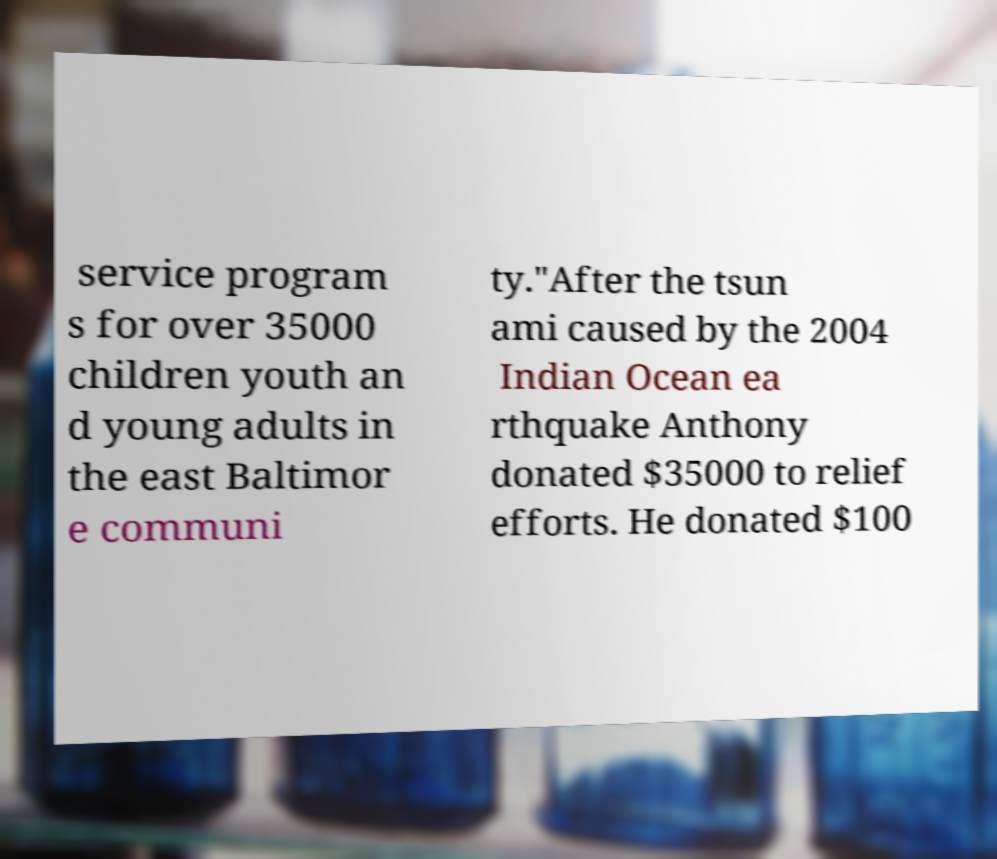What messages or text are displayed in this image? I need them in a readable, typed format. service program s for over 35000 children youth an d young adults in the east Baltimor e communi ty."After the tsun ami caused by the 2004 Indian Ocean ea rthquake Anthony donated $35000 to relief efforts. He donated $100 